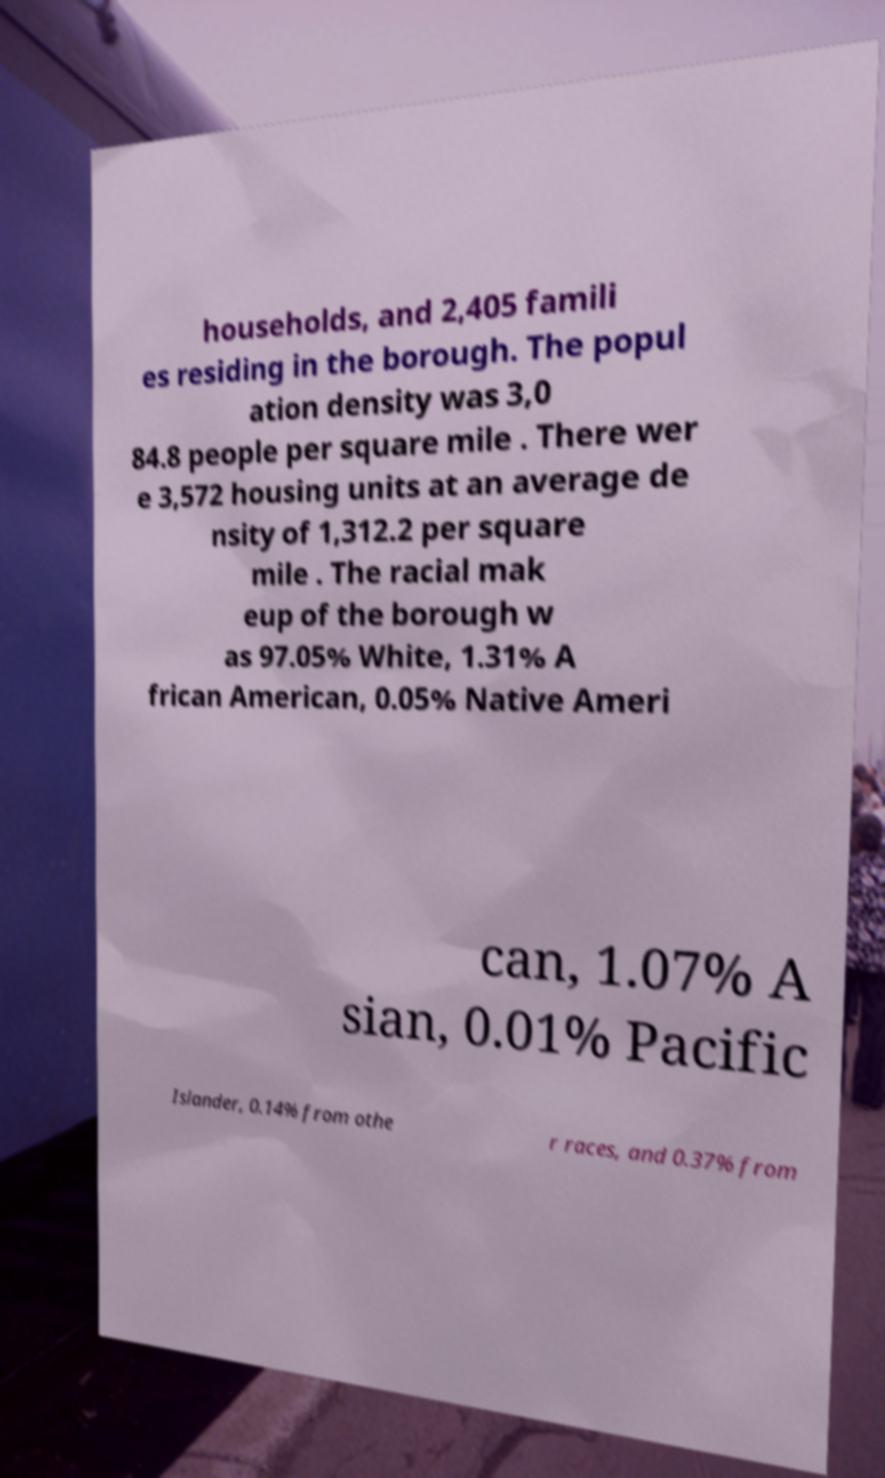I need the written content from this picture converted into text. Can you do that? households, and 2,405 famili es residing in the borough. The popul ation density was 3,0 84.8 people per square mile . There wer e 3,572 housing units at an average de nsity of 1,312.2 per square mile . The racial mak eup of the borough w as 97.05% White, 1.31% A frican American, 0.05% Native Ameri can, 1.07% A sian, 0.01% Pacific Islander, 0.14% from othe r races, and 0.37% from 